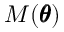<formula> <loc_0><loc_0><loc_500><loc_500>M ( \pm b \theta )</formula> 